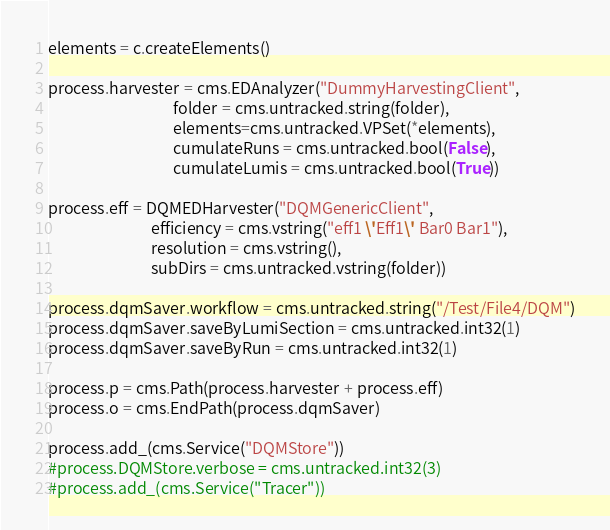<code> <loc_0><loc_0><loc_500><loc_500><_Python_>
elements = c.createElements()

process.harvester = cms.EDAnalyzer("DummyHarvestingClient",
                                   folder = cms.untracked.string(folder),
                                   elements=cms.untracked.VPSet(*elements),
                                   cumulateRuns = cms.untracked.bool(False),
                                   cumulateLumis = cms.untracked.bool(True))

process.eff = DQMEDHarvester("DQMGenericClient",
                             efficiency = cms.vstring("eff1 \'Eff1\' Bar0 Bar1"),
                             resolution = cms.vstring(),
                             subDirs = cms.untracked.vstring(folder))

process.dqmSaver.workflow = cms.untracked.string("/Test/File4/DQM")
process.dqmSaver.saveByLumiSection = cms.untracked.int32(1)
process.dqmSaver.saveByRun = cms.untracked.int32(1)

process.p = cms.Path(process.harvester + process.eff)
process.o = cms.EndPath(process.dqmSaver)

process.add_(cms.Service("DQMStore"))
#process.DQMStore.verbose = cms.untracked.int32(3)
#process.add_(cms.Service("Tracer"))

</code> 